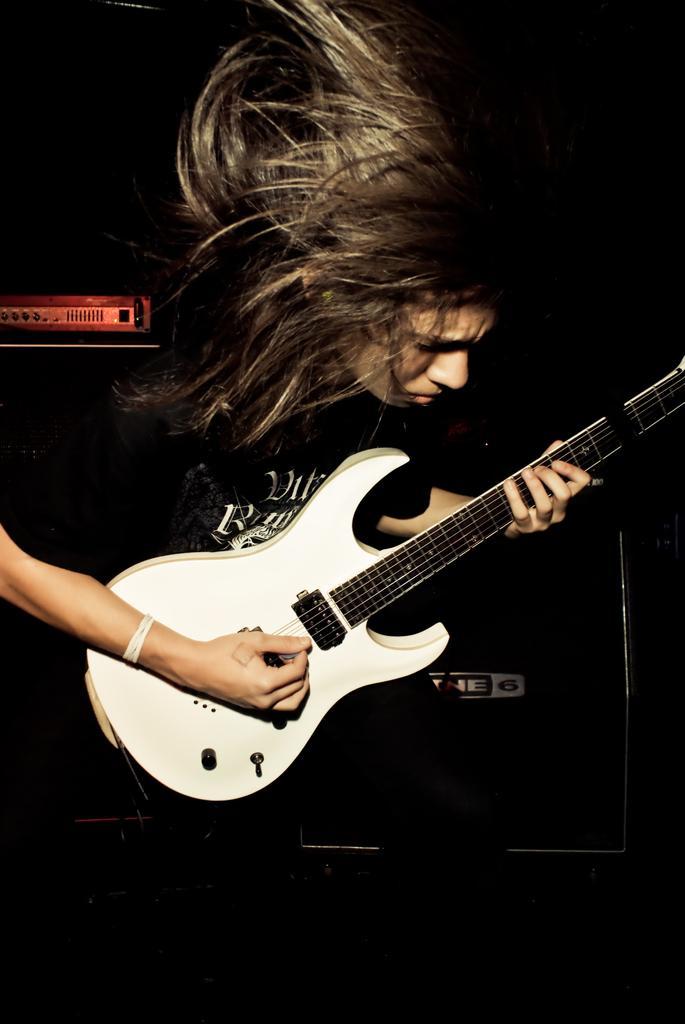In one or two sentences, can you explain what this image depicts? In this image I can see a woman wearing black t shirt, black pant is holding a guitar which is white in color in her hand and I can see a red colored object to the left side of the image and the dark background. 